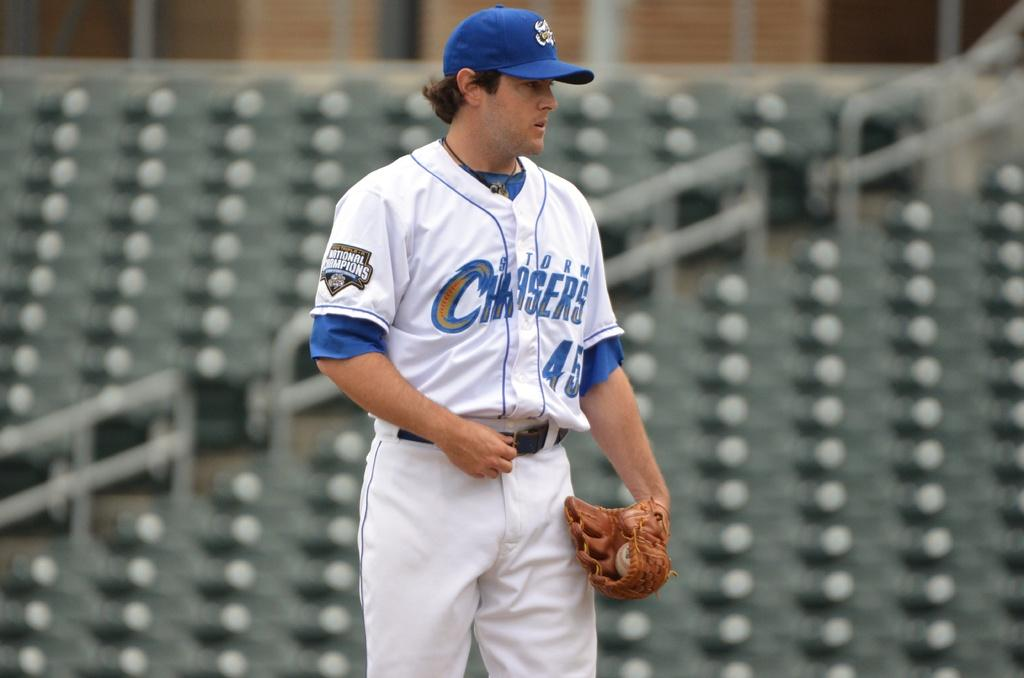Provide a one-sentence caption for the provided image. A baseball player whose number is 45 looking down with gloves on his hands. 